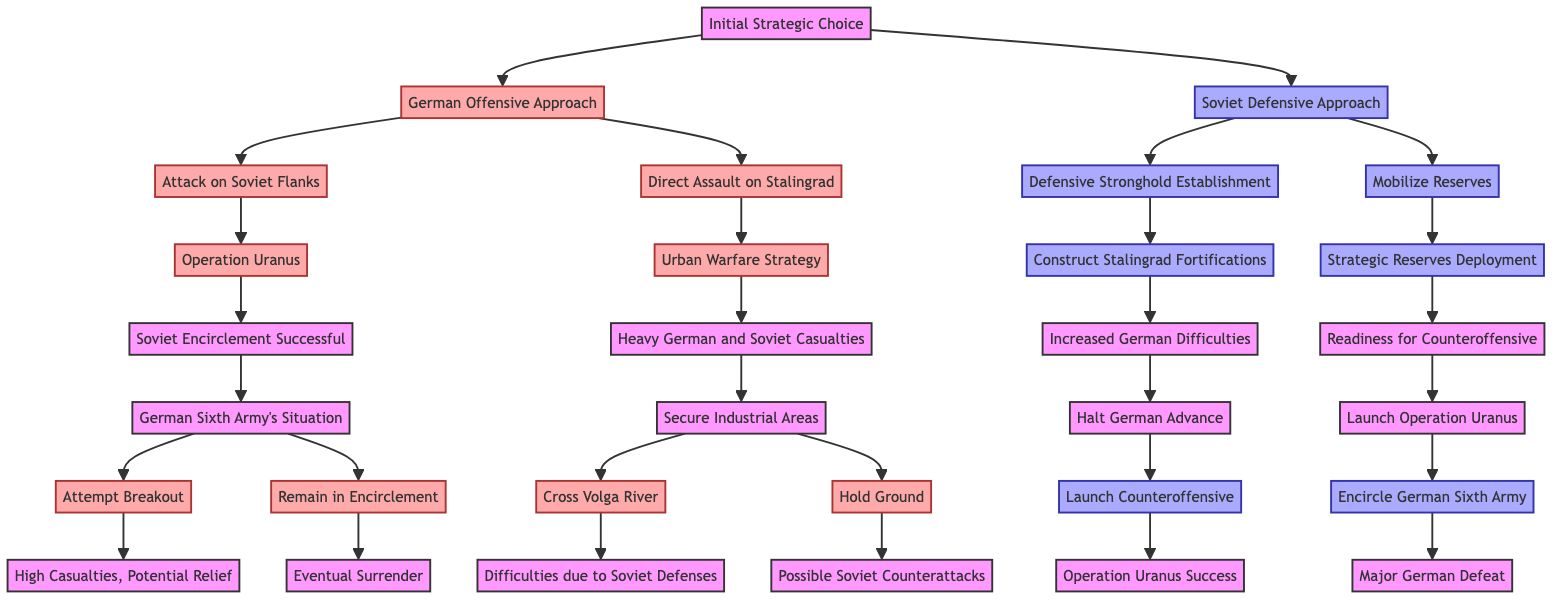What is the initial strategic choice in the diagram? The diagram starts with the node labeled "Initial Strategic Choice", which presents two options: "German Offensive Approach" and "Soviet Defensive Approach." Therefore, the basic information in this node is the two strategic directions available.
Answer: Initial Strategic Choice How many main options are available after the initial strategic choice? The initial strategic choice branches into two main options: "German Offensive Approach" and "Soviet Defensive Approach." Thus, there are a total of two main options available.
Answer: 2 What is the outcome of Operation Uranus? The diagram shows the outcome of "Operation Uranus" as "Soviet Encirclement Successful." Thus, this outcome is directly stated in the relevant part of the diagram.
Answer: Soviet Encirclement Successful What does the German Sixth Army attempt if they remain in encirclement? According to the diagram, if the German Sixth Army chooses to "Remain in Encirclement," the outcome is "Eventual Surrender." This is clearly indicated in the pathway of the decision tree.
Answer: Eventual Surrender What strategy does the Soviet side adopt if they decide to mobilize reserves? The diagram specifies that if the Soviet side chooses to "Mobilize Reserves," this leads them to "Strategic Reserves Deployment" as the next step. Therefore, this is the strategy they adopt in this particular scenario.
Answer: Strategic Reserves Deployment What are the potential outcomes if the Germans cross the Volga River during their urban warfare strategy? The diagram indicates that if the Germans attempt to "Cross Volga River," the outcome is noted as "Difficulties due to Soviet Defenses." Thus, this tells us of the challenges faced if this action is taken.
Answer: Difficulties due to Soviet Defenses What action follows after constructing Stalingrad fortifications? The diagram illustrates that after the "Construct Stalingrad Fortifications" action, the next logical step is to "Halt German Advance." Thus, this is the action that follows in the sequence described.
Answer: Halt German Advance If the Germans decide on a direct assault, what is their warfare strategy? The diagram indicates that if the Germans choose the direct assault option, they adopt the "Urban Warfare Strategy." This is the specific type of warfare they opt for in this scenario.
Answer: Urban Warfare Strategy What is the result of the Soviet counteroffensive after halting the German advance? The decision tree shows that if the Soviets decide to "Launch Counteroffensive," this leads to an outcome of "Operation Uranus Success." Therefore, this describes the result of the Soviets' counteroffensive efforts.
Answer: Operation Uranus Success 